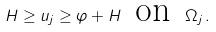Convert formula to latex. <formula><loc_0><loc_0><loc_500><loc_500>H \geq u _ { j } \geq \varphi + H \, \text { on } \, \Omega _ { j } \, .</formula> 